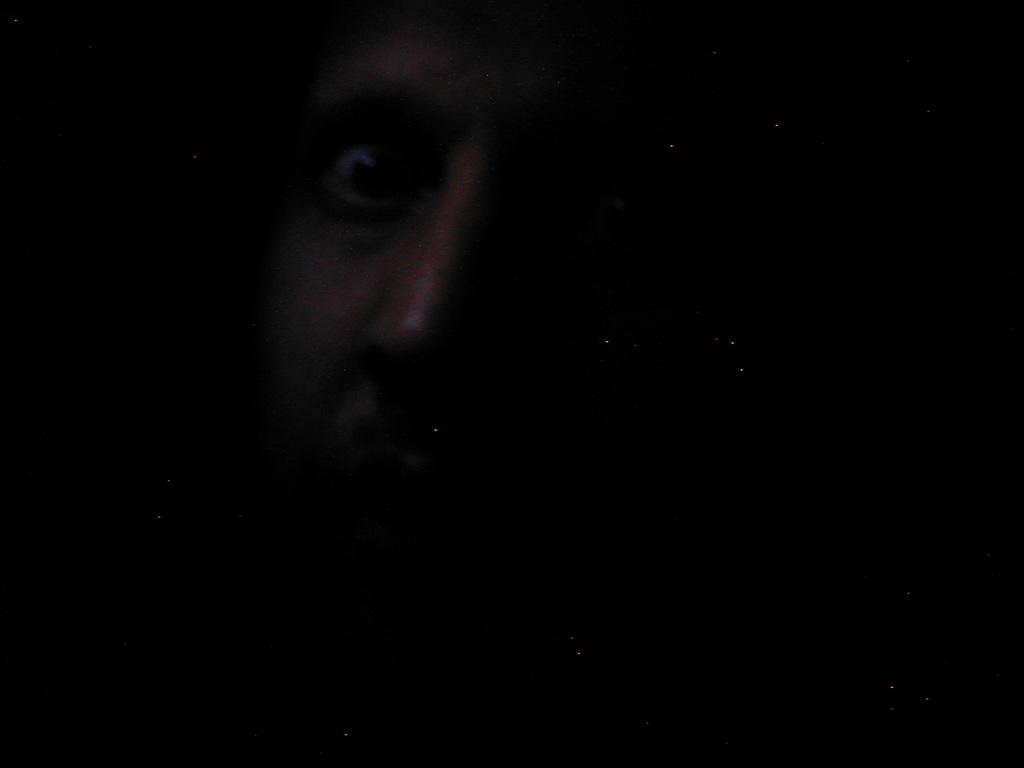What is the overall tone or lighting of the image? The image is dark. What can be seen in the image despite the darkness? There is a person's face visible in the image. How many eggs are present in the image? There are no eggs visible in the image; it only features a person's face in a dark setting. 